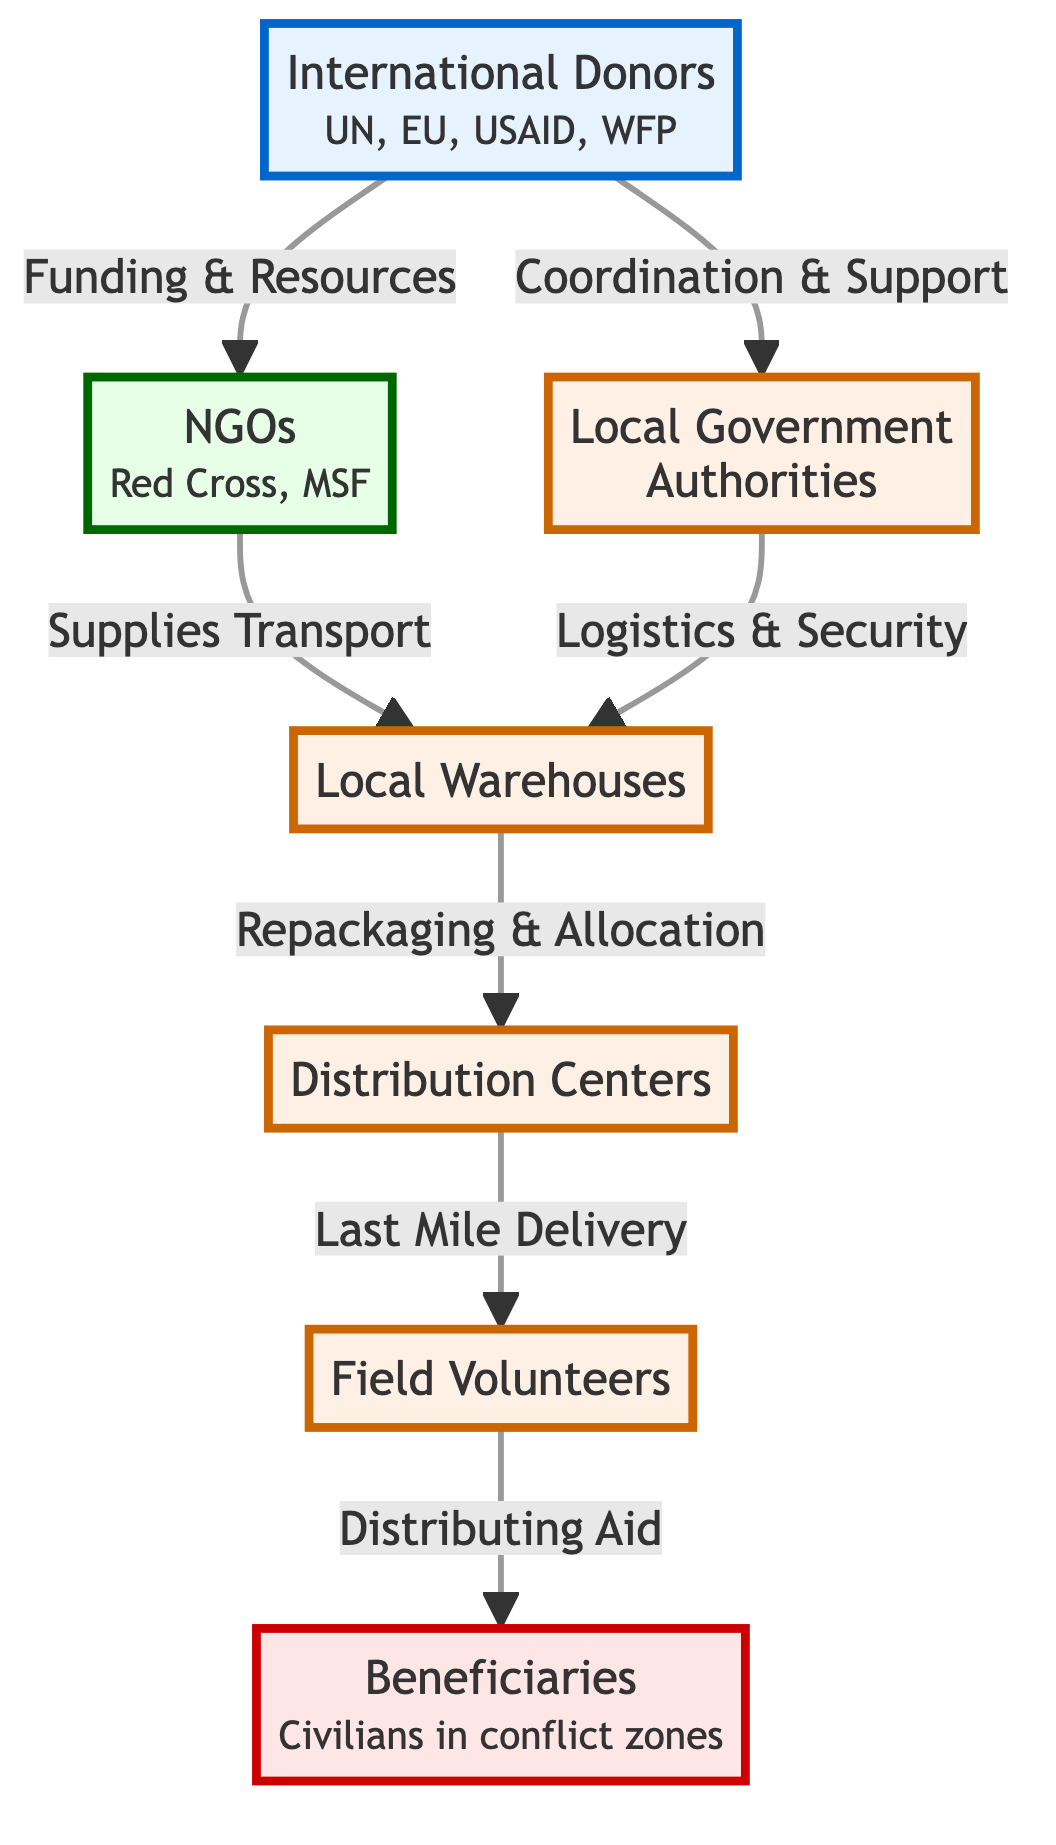What are the two main roles of International Donors? The two main roles of International Donors are to provide Funding & Resources to NGOs and Coordination & Support to Local Government Authorities, as indicated by the arrows stemming from the International Donors node.
Answer: Funding & Resources; Coordination & Support How many local entities are involved in the distribution network? The local entities in the distribution network include Local Warehouses, Distribution Centers, Field Volunteers, and Local Government Authorities. Counting these nodes gives us a total of four local entities involved in the network.
Answer: 4 Which group is responsible for Last Mile Delivery? The group responsible for Last Mile Delivery is Field Volunteers, as indicated by the arrow leading from the Distribution Centers to the Field Volunteers node in the diagram.
Answer: Field Volunteers What connects NGOs to Local Warehouses? The connection between NGOs and Local Warehouses is through Supplies Transport, which is represented as an arrow indicating the direction of flow from NGOs to Local Warehouses.
Answer: Supplies Transport Which two entities collaborate to handle logistics and security? The two entities that collaborate to handle logistics and security are Local Government Authorities and Local Warehouses. This is shown by the arrow flowing from Local Government Authorities to Local Warehouses, indicating collaboration.
Answer: Local Government Authorities; Local Warehouses How many steps are in the flow from International Donors to Beneficiaries? Counting the steps in the flow from International Donors to Beneficiaries, there are five distinct steps: International Donors to NGOs, NGOs to Local Warehouses, Local Warehouses to Distribution Centers, Distribution Centers to Field Volunteers, and Field Volunteers to Beneficiaries.
Answer: 5 What is the role of NGOs in this distribution network? The role of NGOs in this distribution network includes transporting supplies to Local Warehouses, as indicated by the direct connection and flow from NGOs to Local Warehouses in the diagram.
Answer: Supplies Transport Who primarily benefits from the aid distributed in conflict zones? The primary beneficiaries of the aid distributed in conflict zones are civilians, as denoted in the Beneficiaries node in the diagram, which specifies that it includes Civilians in conflict zones.
Answer: Civilians in conflict zones 